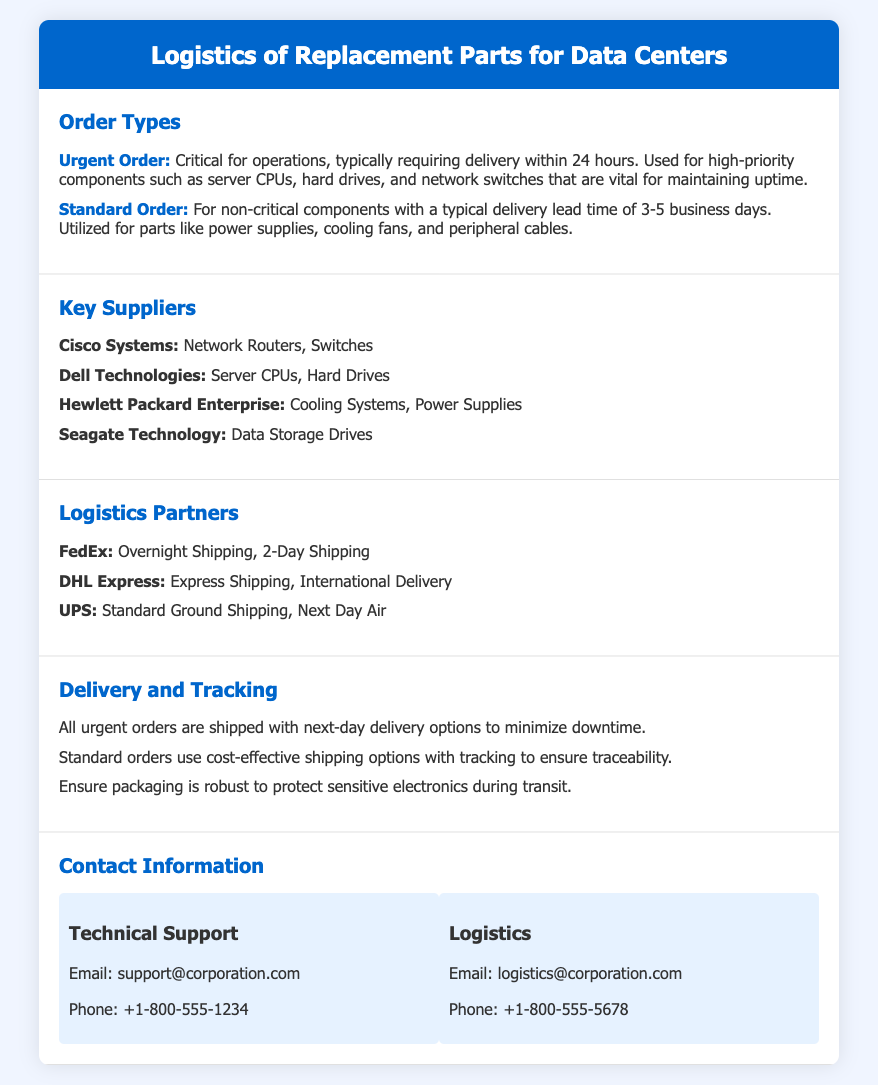What is the typical delivery time for a Standard Order? The document specifies that Standard Orders have a typical delivery lead time of 3-5 business days.
Answer: 3-5 business days Which supplier provides Network Routers? Cisco Systems is listed as the supplier for Network Routers.
Answer: Cisco Systems What is the contact phone number for Technical Support? The document includes the Technical Support contact phone number as +1-800-555-1234.
Answer: +1-800-555-1234 What is emphasized for urgent orders in terms of delivery? Urgent orders are emphasized to be shipped with next-day delivery options to minimize downtime.
Answer: Next-day delivery Name one logistics partner that handles overnight shipping. FedEx is listed as a logistics partner that offers overnight shipping.
Answer: FedEx How long does it take to deliver urgent orders? The document indicates that urgent orders typically require delivery within 24 hours.
Answer: 24 hours What kind of components are generally classified under urgent orders? The document states that urgent orders are classified for high-priority components such as server CPUs and network switches.
Answer: Server CPUs, Network Switches What is the primary purpose of robust packaging mentioned in the document? The document highlights that robust packaging is necessary to protect sensitive electronics during transit.
Answer: Protect sensitive electronics Which email should be contacted for logistics inquiries? The document provides the email logistics@corporation.com for logistics inquiries.
Answer: logistics@corporation.com 